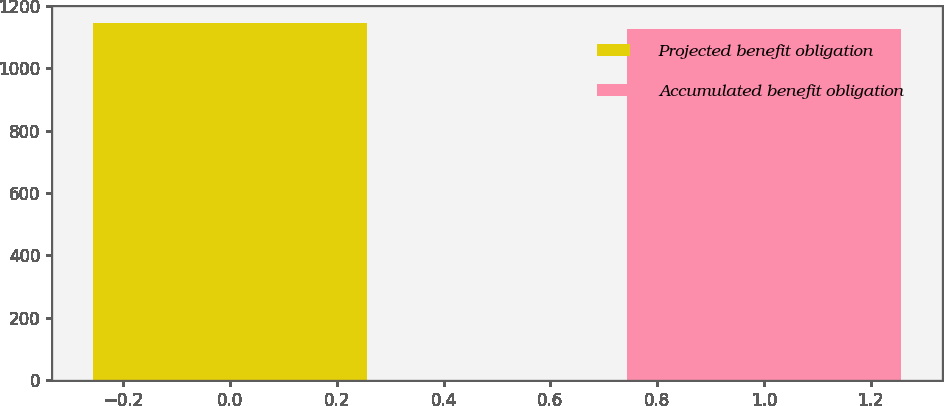Convert chart. <chart><loc_0><loc_0><loc_500><loc_500><bar_chart><fcel>Projected benefit obligation<fcel>Accumulated benefit obligation<nl><fcel>1144<fcel>1126<nl></chart> 